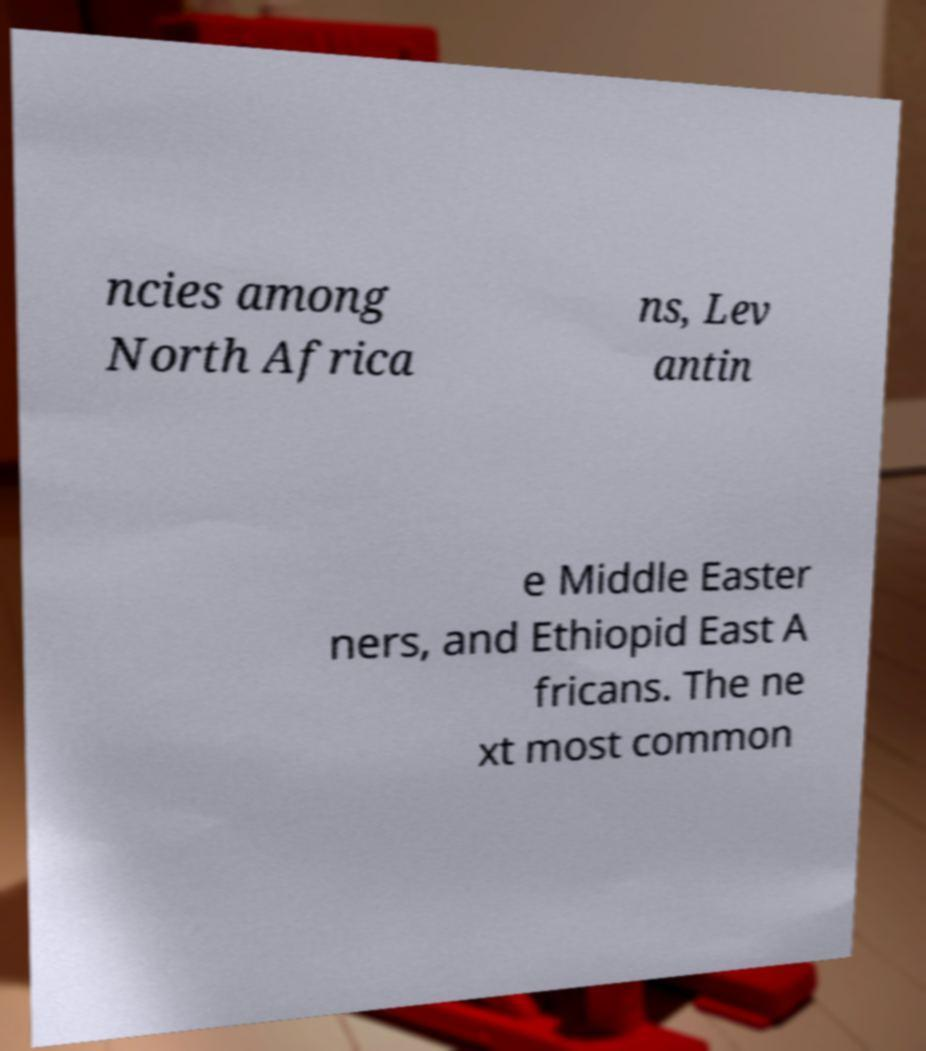Could you assist in decoding the text presented in this image and type it out clearly? ncies among North Africa ns, Lev antin e Middle Easter ners, and Ethiopid East A fricans. The ne xt most common 